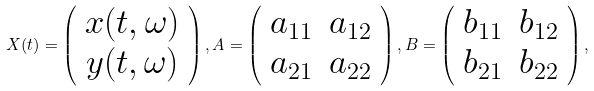<formula> <loc_0><loc_0><loc_500><loc_500>X ( t ) = \left ( \begin{array} { c } x ( t , \omega ) \\ y ( t , \omega ) \end{array} \right ) , A = \left ( \begin{array} { c c } a _ { 1 1 } & a _ { 1 2 } \\ a _ { 2 1 } & a _ { 2 2 } \end{array} \right ) , B = \left ( \begin{array} { c c } b _ { 1 1 } & b _ { 1 2 } \\ b _ { 2 1 } & b _ { 2 2 } \end{array} \right ) ,</formula> 